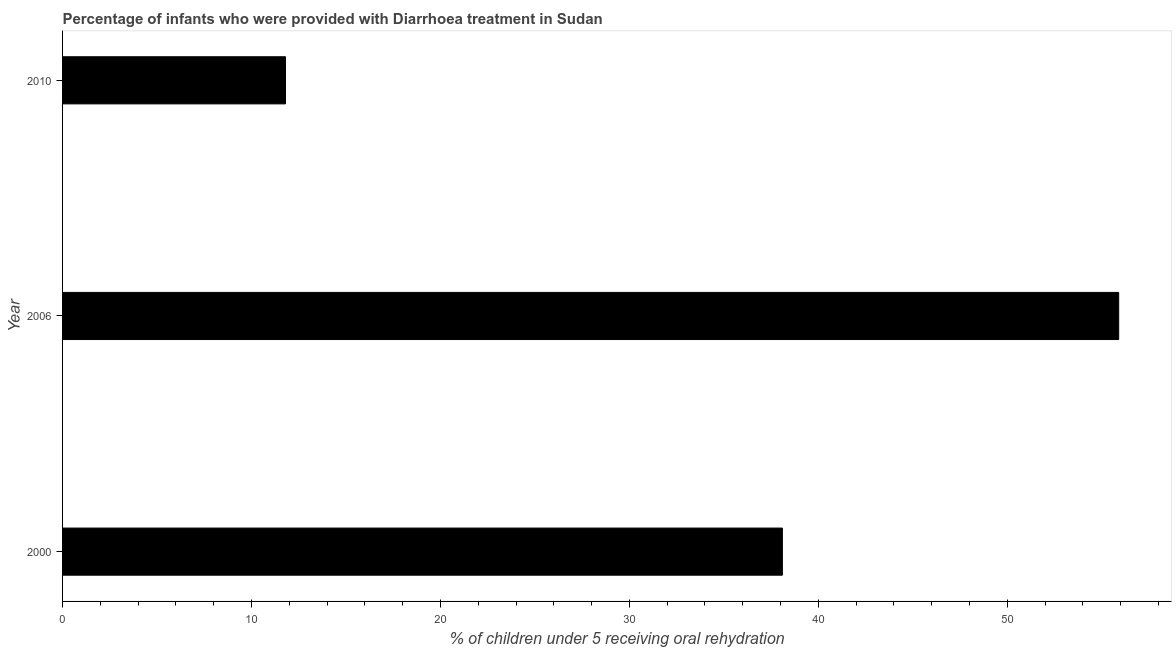Does the graph contain any zero values?
Keep it short and to the point. No. What is the title of the graph?
Provide a succinct answer. Percentage of infants who were provided with Diarrhoea treatment in Sudan. What is the label or title of the X-axis?
Your answer should be very brief. % of children under 5 receiving oral rehydration. What is the label or title of the Y-axis?
Provide a succinct answer. Year. What is the percentage of children who were provided with treatment diarrhoea in 2006?
Offer a very short reply. 55.9. Across all years, what is the maximum percentage of children who were provided with treatment diarrhoea?
Provide a short and direct response. 55.9. Across all years, what is the minimum percentage of children who were provided with treatment diarrhoea?
Keep it short and to the point. 11.8. In which year was the percentage of children who were provided with treatment diarrhoea maximum?
Give a very brief answer. 2006. What is the sum of the percentage of children who were provided with treatment diarrhoea?
Your response must be concise. 105.8. What is the difference between the percentage of children who were provided with treatment diarrhoea in 2000 and 2010?
Provide a succinct answer. 26.3. What is the average percentage of children who were provided with treatment diarrhoea per year?
Provide a succinct answer. 35.27. What is the median percentage of children who were provided with treatment diarrhoea?
Make the answer very short. 38.1. In how many years, is the percentage of children who were provided with treatment diarrhoea greater than 28 %?
Keep it short and to the point. 2. Do a majority of the years between 2006 and 2010 (inclusive) have percentage of children who were provided with treatment diarrhoea greater than 42 %?
Make the answer very short. No. What is the ratio of the percentage of children who were provided with treatment diarrhoea in 2000 to that in 2010?
Your answer should be compact. 3.23. What is the difference between the highest and the second highest percentage of children who were provided with treatment diarrhoea?
Provide a short and direct response. 17.8. Is the sum of the percentage of children who were provided with treatment diarrhoea in 2006 and 2010 greater than the maximum percentage of children who were provided with treatment diarrhoea across all years?
Provide a succinct answer. Yes. What is the difference between the highest and the lowest percentage of children who were provided with treatment diarrhoea?
Give a very brief answer. 44.1. In how many years, is the percentage of children who were provided with treatment diarrhoea greater than the average percentage of children who were provided with treatment diarrhoea taken over all years?
Keep it short and to the point. 2. How many years are there in the graph?
Offer a terse response. 3. Are the values on the major ticks of X-axis written in scientific E-notation?
Your answer should be compact. No. What is the % of children under 5 receiving oral rehydration in 2000?
Provide a short and direct response. 38.1. What is the % of children under 5 receiving oral rehydration of 2006?
Ensure brevity in your answer.  55.9. What is the % of children under 5 receiving oral rehydration of 2010?
Provide a succinct answer. 11.8. What is the difference between the % of children under 5 receiving oral rehydration in 2000 and 2006?
Your answer should be compact. -17.8. What is the difference between the % of children under 5 receiving oral rehydration in 2000 and 2010?
Keep it short and to the point. 26.3. What is the difference between the % of children under 5 receiving oral rehydration in 2006 and 2010?
Your answer should be compact. 44.1. What is the ratio of the % of children under 5 receiving oral rehydration in 2000 to that in 2006?
Make the answer very short. 0.68. What is the ratio of the % of children under 5 receiving oral rehydration in 2000 to that in 2010?
Offer a terse response. 3.23. What is the ratio of the % of children under 5 receiving oral rehydration in 2006 to that in 2010?
Your answer should be compact. 4.74. 